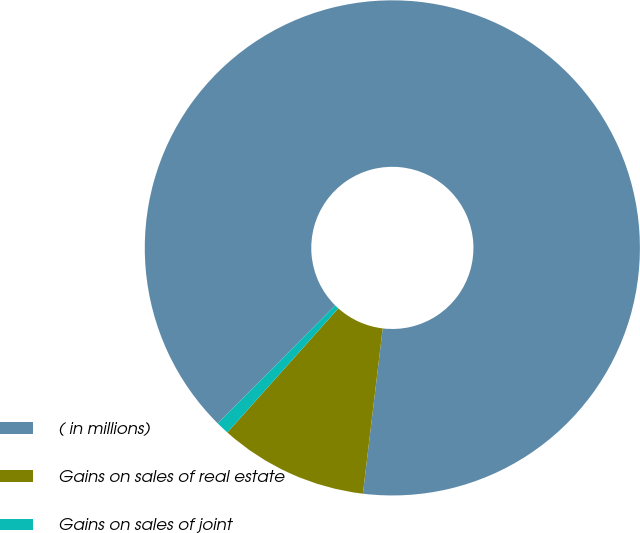<chart> <loc_0><loc_0><loc_500><loc_500><pie_chart><fcel>( in millions)<fcel>Gains on sales of real estate<fcel>Gains on sales of joint<nl><fcel>89.44%<fcel>9.71%<fcel>0.85%<nl></chart> 